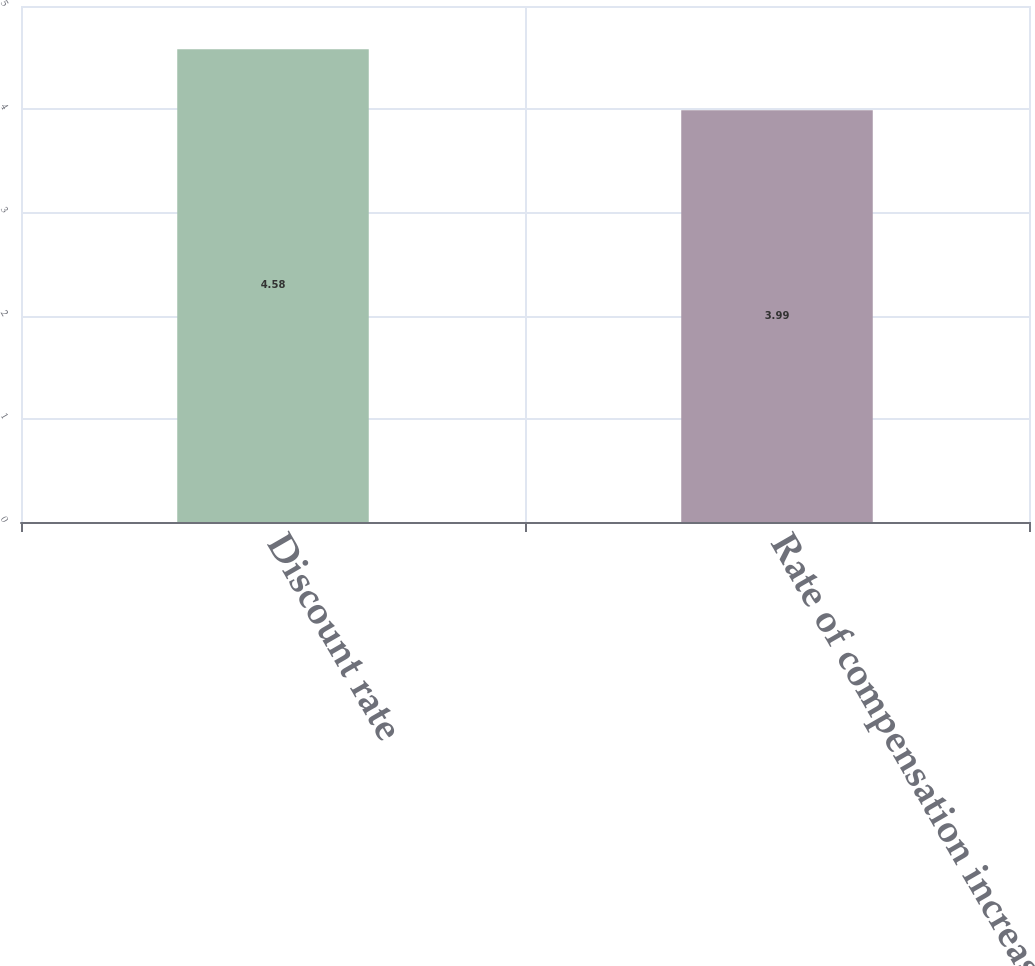Convert chart to OTSL. <chart><loc_0><loc_0><loc_500><loc_500><bar_chart><fcel>Discount rate<fcel>Rate of compensation increase<nl><fcel>4.58<fcel>3.99<nl></chart> 